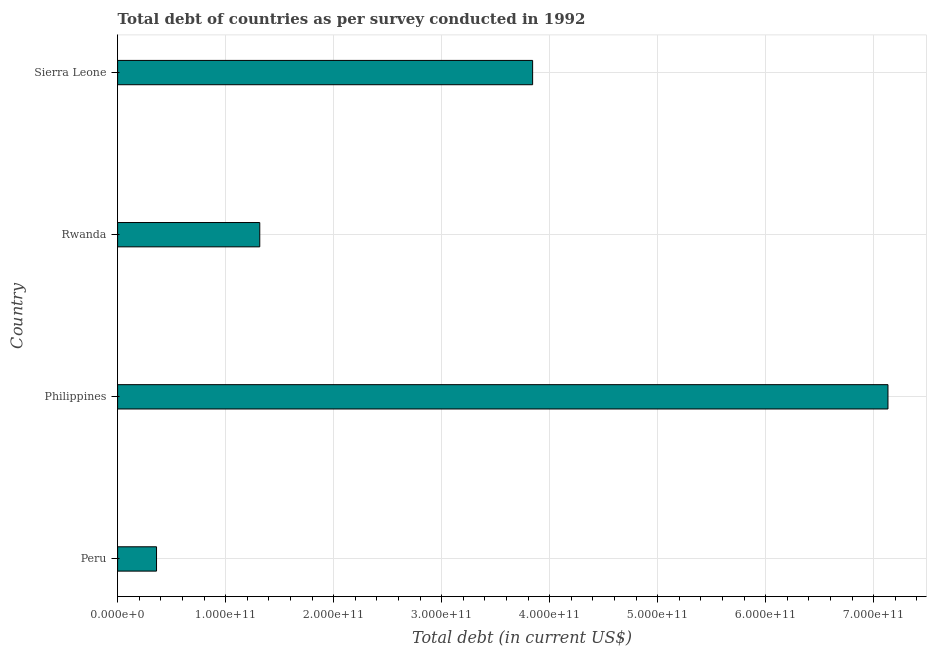Does the graph contain grids?
Make the answer very short. Yes. What is the title of the graph?
Give a very brief answer. Total debt of countries as per survey conducted in 1992. What is the label or title of the X-axis?
Provide a succinct answer. Total debt (in current US$). What is the label or title of the Y-axis?
Offer a terse response. Country. What is the total debt in Rwanda?
Provide a short and direct response. 1.32e+11. Across all countries, what is the maximum total debt?
Ensure brevity in your answer.  7.13e+11. Across all countries, what is the minimum total debt?
Provide a succinct answer. 3.60e+1. In which country was the total debt maximum?
Give a very brief answer. Philippines. In which country was the total debt minimum?
Offer a very short reply. Peru. What is the sum of the total debt?
Offer a very short reply. 1.27e+12. What is the difference between the total debt in Peru and Rwanda?
Make the answer very short. -9.56e+1. What is the average total debt per country?
Your response must be concise. 3.16e+11. What is the median total debt?
Your answer should be very brief. 2.58e+11. In how many countries, is the total debt greater than 500000000000 US$?
Give a very brief answer. 1. What is the ratio of the total debt in Peru to that in Philippines?
Offer a terse response. 0.05. Is the difference between the total debt in Peru and Philippines greater than the difference between any two countries?
Offer a terse response. Yes. What is the difference between the highest and the second highest total debt?
Your response must be concise. 3.29e+11. Is the sum of the total debt in Peru and Sierra Leone greater than the maximum total debt across all countries?
Provide a short and direct response. No. What is the difference between the highest and the lowest total debt?
Ensure brevity in your answer.  6.77e+11. In how many countries, is the total debt greater than the average total debt taken over all countries?
Offer a terse response. 2. How many bars are there?
Offer a very short reply. 4. Are all the bars in the graph horizontal?
Offer a terse response. Yes. What is the difference between two consecutive major ticks on the X-axis?
Keep it short and to the point. 1.00e+11. Are the values on the major ticks of X-axis written in scientific E-notation?
Your answer should be very brief. Yes. What is the Total debt (in current US$) in Peru?
Offer a terse response. 3.60e+1. What is the Total debt (in current US$) of Philippines?
Ensure brevity in your answer.  7.13e+11. What is the Total debt (in current US$) of Rwanda?
Make the answer very short. 1.32e+11. What is the Total debt (in current US$) in Sierra Leone?
Offer a terse response. 3.84e+11. What is the difference between the Total debt (in current US$) in Peru and Philippines?
Offer a terse response. -6.77e+11. What is the difference between the Total debt (in current US$) in Peru and Rwanda?
Ensure brevity in your answer.  -9.56e+1. What is the difference between the Total debt (in current US$) in Peru and Sierra Leone?
Your answer should be very brief. -3.48e+11. What is the difference between the Total debt (in current US$) in Philippines and Rwanda?
Provide a short and direct response. 5.82e+11. What is the difference between the Total debt (in current US$) in Philippines and Sierra Leone?
Your answer should be compact. 3.29e+11. What is the difference between the Total debt (in current US$) in Rwanda and Sierra Leone?
Give a very brief answer. -2.53e+11. What is the ratio of the Total debt (in current US$) in Peru to that in Philippines?
Offer a terse response. 0.05. What is the ratio of the Total debt (in current US$) in Peru to that in Rwanda?
Keep it short and to the point. 0.27. What is the ratio of the Total debt (in current US$) in Peru to that in Sierra Leone?
Ensure brevity in your answer.  0.09. What is the ratio of the Total debt (in current US$) in Philippines to that in Rwanda?
Your answer should be very brief. 5.42. What is the ratio of the Total debt (in current US$) in Philippines to that in Sierra Leone?
Your answer should be compact. 1.86. What is the ratio of the Total debt (in current US$) in Rwanda to that in Sierra Leone?
Provide a short and direct response. 0.34. 